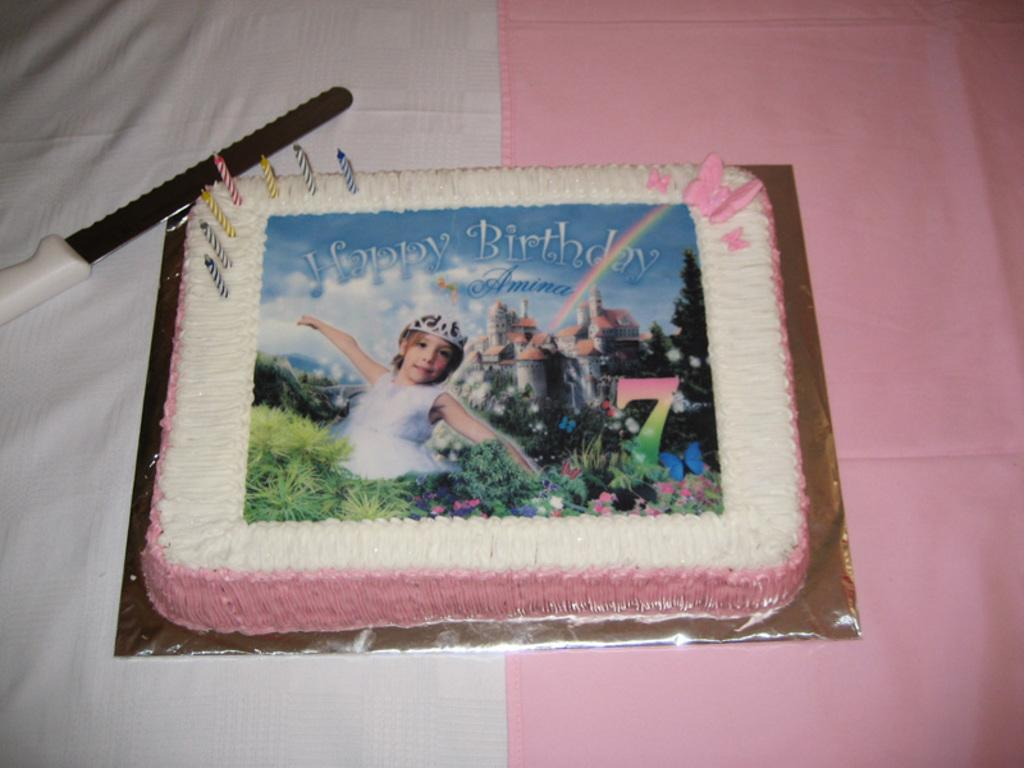What is present on the surface in the image? There is a cake and a knife on the surface in the image. Can you describe the design on the cake? The cake has a design featuring a girl, buildings, and plants. What type of train can be seen passing through the cave in the image? There is no train or cave present in the image; it features a cake with a design of a girl, buildings, and plants. 